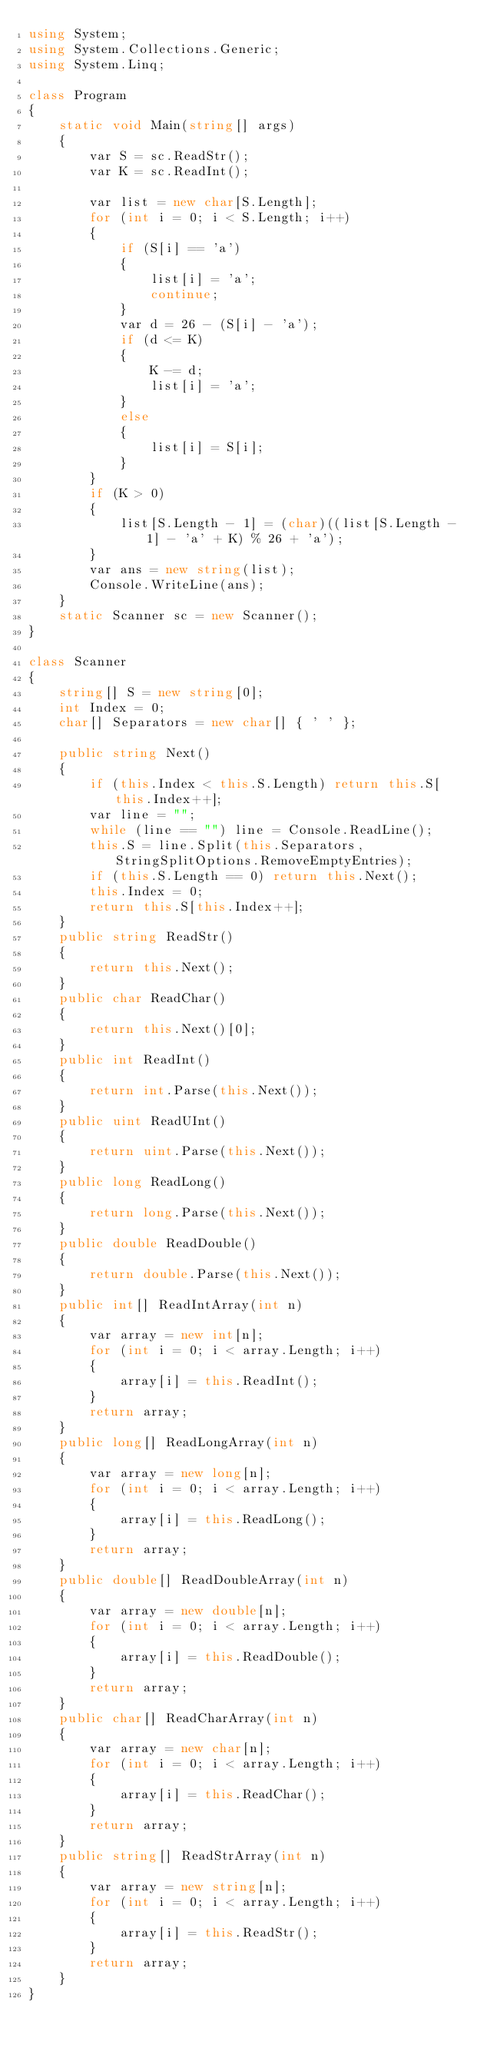Convert code to text. <code><loc_0><loc_0><loc_500><loc_500><_C#_>using System;
using System.Collections.Generic;
using System.Linq;

class Program
{
    static void Main(string[] args)
    {
        var S = sc.ReadStr();
        var K = sc.ReadInt();

        var list = new char[S.Length];
        for (int i = 0; i < S.Length; i++)
        {
            if (S[i] == 'a')
            {
                list[i] = 'a';
                continue;
            }
            var d = 26 - (S[i] - 'a');
            if (d <= K)
            {
                K -= d;
                list[i] = 'a';
            }
            else
            {
                list[i] = S[i];
            }
        }
        if (K > 0)
        {
            list[S.Length - 1] = (char)((list[S.Length - 1] - 'a' + K) % 26 + 'a');
        }
        var ans = new string(list);
        Console.WriteLine(ans);
    }
    static Scanner sc = new Scanner();
}

class Scanner
{
    string[] S = new string[0];
    int Index = 0;
    char[] Separators = new char[] { ' ' };

    public string Next()
    {
        if (this.Index < this.S.Length) return this.S[this.Index++];
        var line = "";
        while (line == "") line = Console.ReadLine();
        this.S = line.Split(this.Separators, StringSplitOptions.RemoveEmptyEntries);
        if (this.S.Length == 0) return this.Next();
        this.Index = 0;
        return this.S[this.Index++];
    }
    public string ReadStr()
    {
        return this.Next();
    }
    public char ReadChar()
    {
        return this.Next()[0];
    }
    public int ReadInt()
    {
        return int.Parse(this.Next());
    }
    public uint ReadUInt()
    {
        return uint.Parse(this.Next());
    }
    public long ReadLong()
    {
        return long.Parse(this.Next());
    }
    public double ReadDouble()
    {
        return double.Parse(this.Next());
    }
    public int[] ReadIntArray(int n)
    {
        var array = new int[n];
        for (int i = 0; i < array.Length; i++)
        {
            array[i] = this.ReadInt();
        }
        return array;
    }
    public long[] ReadLongArray(int n)
    {
        var array = new long[n];
        for (int i = 0; i < array.Length; i++)
        {
            array[i] = this.ReadLong();
        }
        return array;
    }
    public double[] ReadDoubleArray(int n)
    {
        var array = new double[n];
        for (int i = 0; i < array.Length; i++)
        {
            array[i] = this.ReadDouble();
        }
        return array;
    }
    public char[] ReadCharArray(int n)
    {
        var array = new char[n];
        for (int i = 0; i < array.Length; i++)
        {
            array[i] = this.ReadChar();
        }
        return array;
    }
    public string[] ReadStrArray(int n)
    {
        var array = new string[n];
        for (int i = 0; i < array.Length; i++)
        {
            array[i] = this.ReadStr();
        }
        return array;
    }
}
</code> 